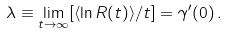<formula> <loc_0><loc_0><loc_500><loc_500>\lambda \equiv \lim _ { t \to \infty } [ \langle \ln R ( t ) \rangle / t ] = \gamma ^ { \prime } ( 0 ) \, .</formula> 